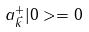Convert formula to latex. <formula><loc_0><loc_0><loc_500><loc_500>a _ { \vec { k } } ^ { + } | 0 > = 0</formula> 